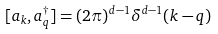Convert formula to latex. <formula><loc_0><loc_0><loc_500><loc_500>[ a _ { k } , a ^ { \dagger } _ { q } ] = ( 2 \pi ) ^ { d - 1 } \delta ^ { d - 1 } ( k - q )</formula> 